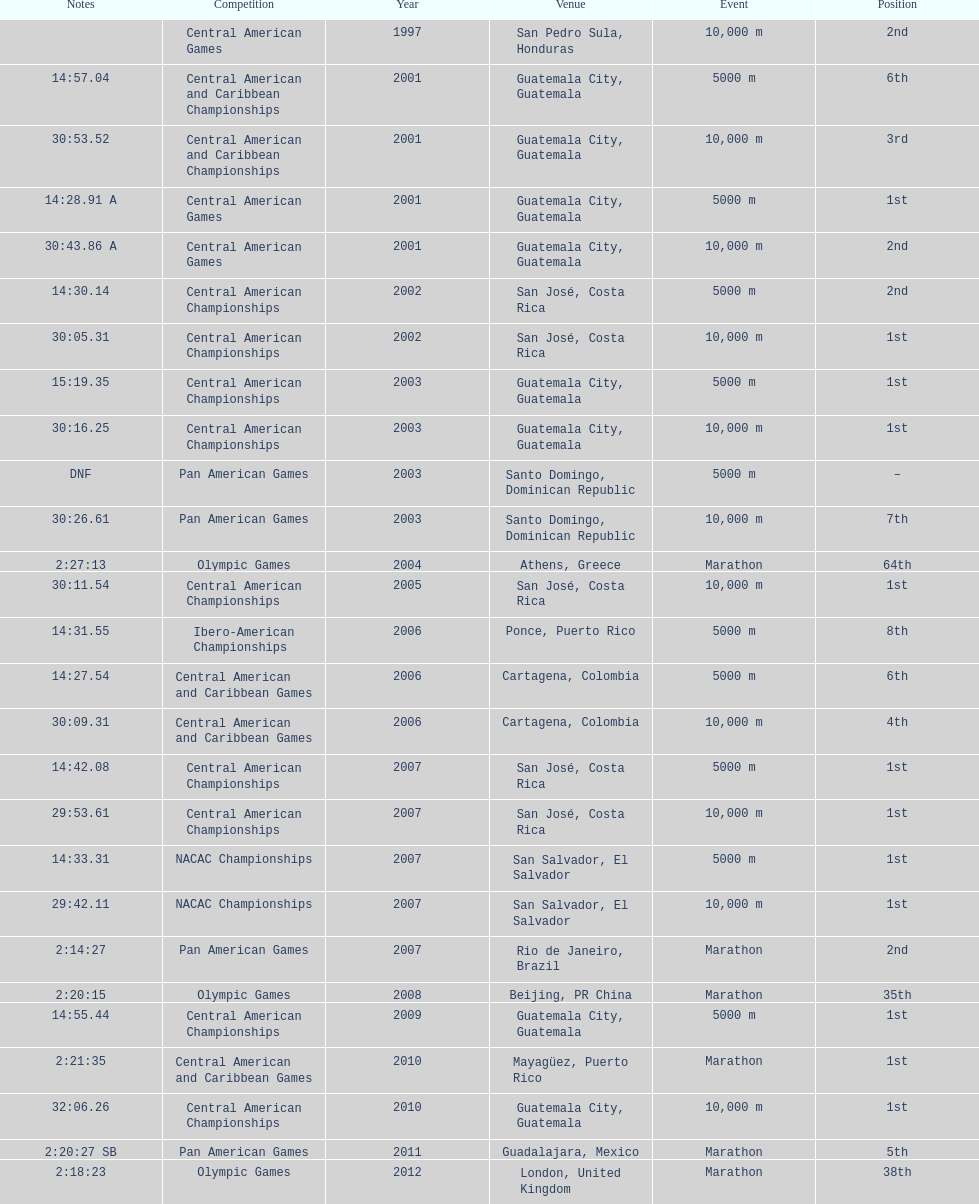Tell me the number of times they competed in guatamala. 5. 